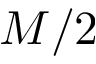Convert formula to latex. <formula><loc_0><loc_0><loc_500><loc_500>M / 2</formula> 